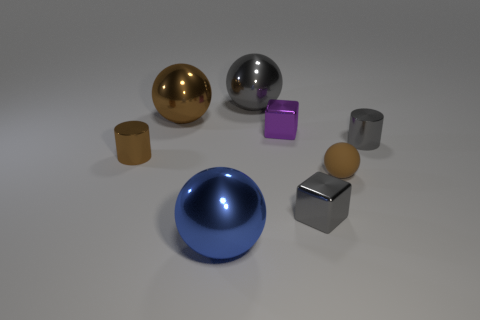Subtract all large blue metal balls. How many balls are left? 3 Subtract all gray cylinders. How many cylinders are left? 1 Subtract 0 yellow balls. How many objects are left? 8 Subtract all cylinders. How many objects are left? 6 Subtract 1 cylinders. How many cylinders are left? 1 Subtract all gray blocks. Subtract all red cylinders. How many blocks are left? 1 Subtract all brown cylinders. How many purple blocks are left? 1 Subtract all gray shiny cylinders. Subtract all brown metal spheres. How many objects are left? 6 Add 1 gray things. How many gray things are left? 4 Add 2 brown objects. How many brown objects exist? 5 